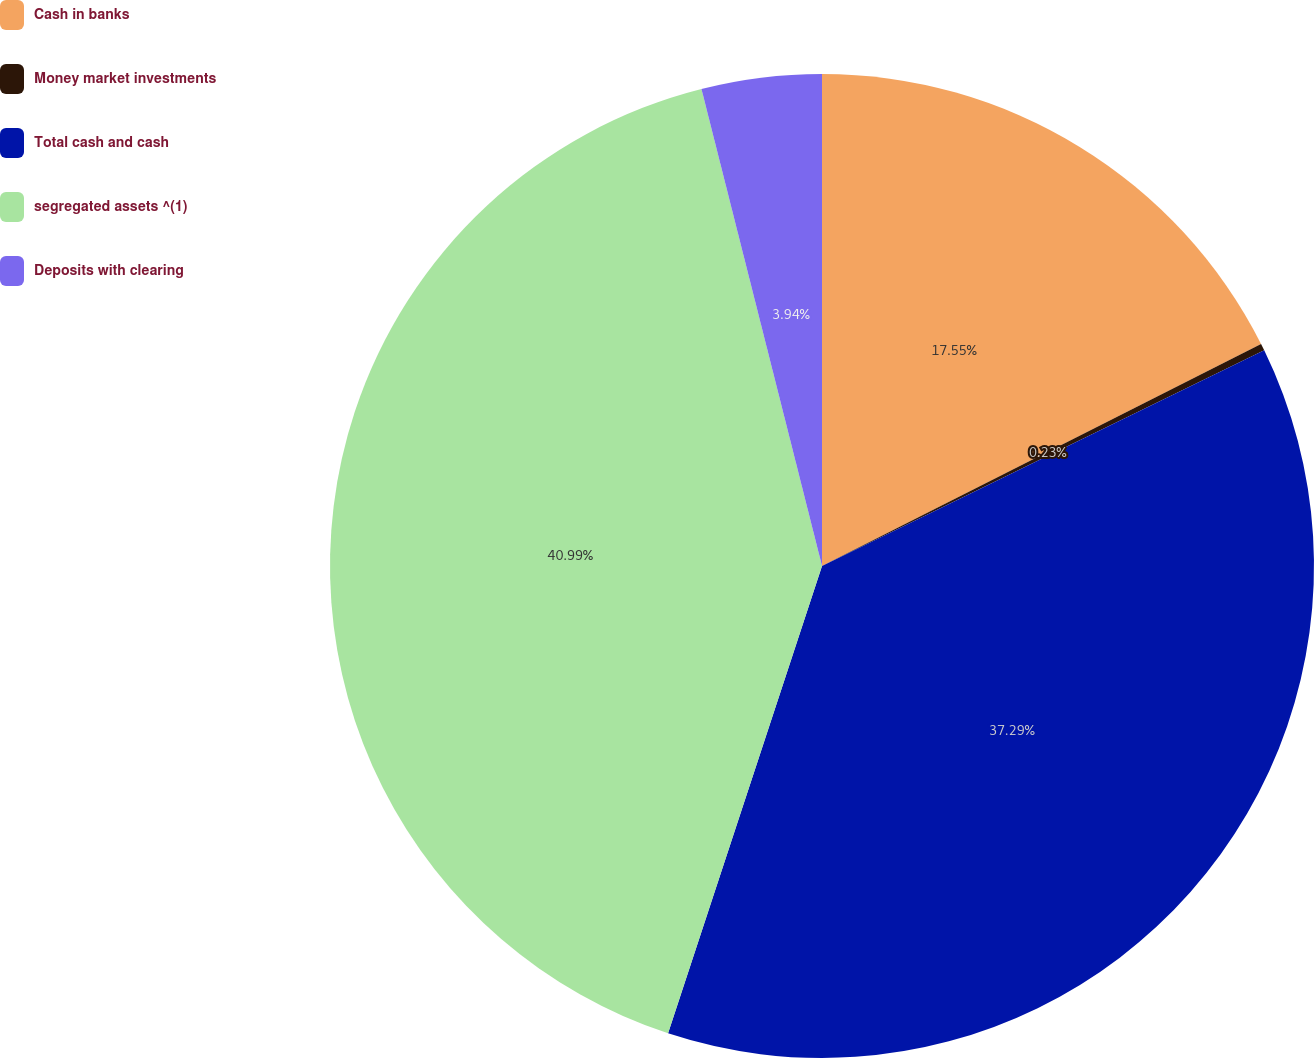Convert chart to OTSL. <chart><loc_0><loc_0><loc_500><loc_500><pie_chart><fcel>Cash in banks<fcel>Money market investments<fcel>Total cash and cash<fcel>segregated assets ^(1)<fcel>Deposits with clearing<nl><fcel>17.55%<fcel>0.23%<fcel>37.29%<fcel>41.0%<fcel>3.94%<nl></chart> 